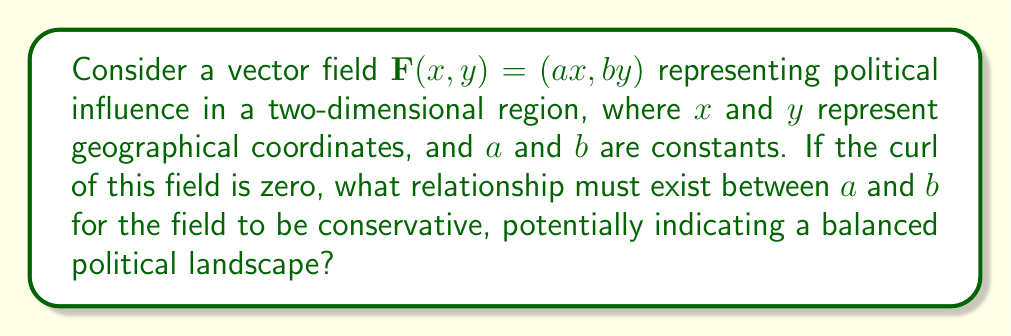Can you answer this question? To determine if the vector field is conservative, we need to calculate its curl and set it to zero. Let's approach this step-by-step:

1) The curl of a two-dimensional vector field $\mathbf{F}(x,y) = (P(x,y), Q(x,y))$ is given by:

   $\text{curl } \mathbf{F} = \frac{\partial Q}{\partial x} - \frac{\partial P}{\partial y}$

2) In our case, $P(x,y) = ax$ and $Q(x,y) = by$. Let's calculate the partial derivatives:

   $\frac{\partial Q}{\partial x} = \frac{\partial (by)}{\partial x} = 0$
   $\frac{\partial P}{\partial y} = \frac{\partial (ax)}{\partial y} = 0$

3) Now, let's set up the curl equation:

   $\text{curl } \mathbf{F} = \frac{\partial Q}{\partial x} - \frac{\partial P}{\partial y} = 0 - 0 = 0$

4) We can see that the curl is always zero for this vector field, regardless of the values of $a$ and $b$. This means the field is always conservative.

5) In political science terms, this suggests that the influence modeled by this field is "balanced" or "path-independent" - the total influence between any two points doesn't depend on the path taken between them.

6) While no specific relationship between $a$ and $b$ is required for the field to be conservative, their values would affect the strength and direction of influence in different parts of the region.
Answer: No specific relationship required; $a$ and $b$ can be any constants. 